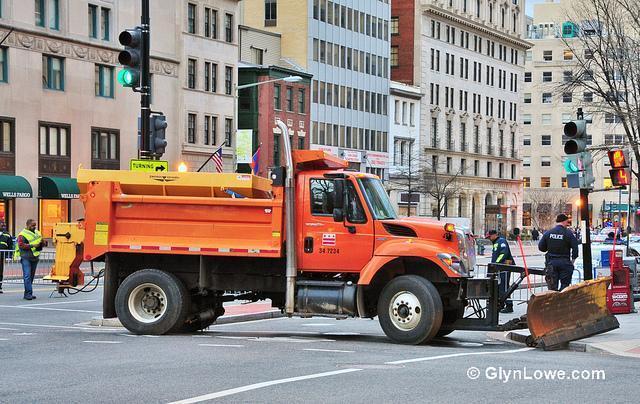How many dogs are there?
Give a very brief answer. 0. 